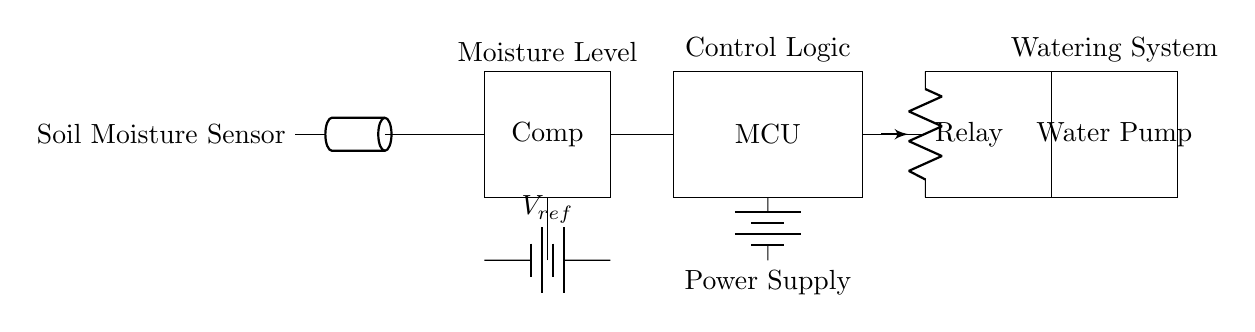What is the purpose of the moisture sensor? The moisture sensor detects the moisture level in the soil, providing feedback on whether the soil is too dry or adequately moist. This information is crucial for deciding when to activate the watering system.
Answer: Detect moisture level What component is used for control logic? The control logic is managed by a microcontroller, which processes the sensor input and decides when to activate the watering system based on the moisture level.
Answer: Microcontroller What is the reference voltage in the circuit labeled as? The reference voltage is denoted with the label V_ref, which sets a threshold for the moisture level that the comparator uses to activate the microcontroller's watering decision.
Answer: V_ref Which component activates the water pump? The relay is responsible for activating the water pump based on signals from the microcontroller, controlling the flow of electricity to the pump.
Answer: Relay What type of sensor is used in this circuit? The circuit utilizes a soil moisture sensor, specifically designed to measure the moisture content of soil.
Answer: Soil moisture sensor How does the moisture level affect the watering system? The moisture level is compared against the reference voltage; if the moisture level is below the threshold, the microcontroller activates the relay to turn on the water pump, ensuring plants receive adequate watering.
Answer: Below threshold activates watering What is the final output component of the control circuit? The final output component is the water pump, which delivers water to the plant beds when activated, providing moisture as needed.
Answer: Water pump 